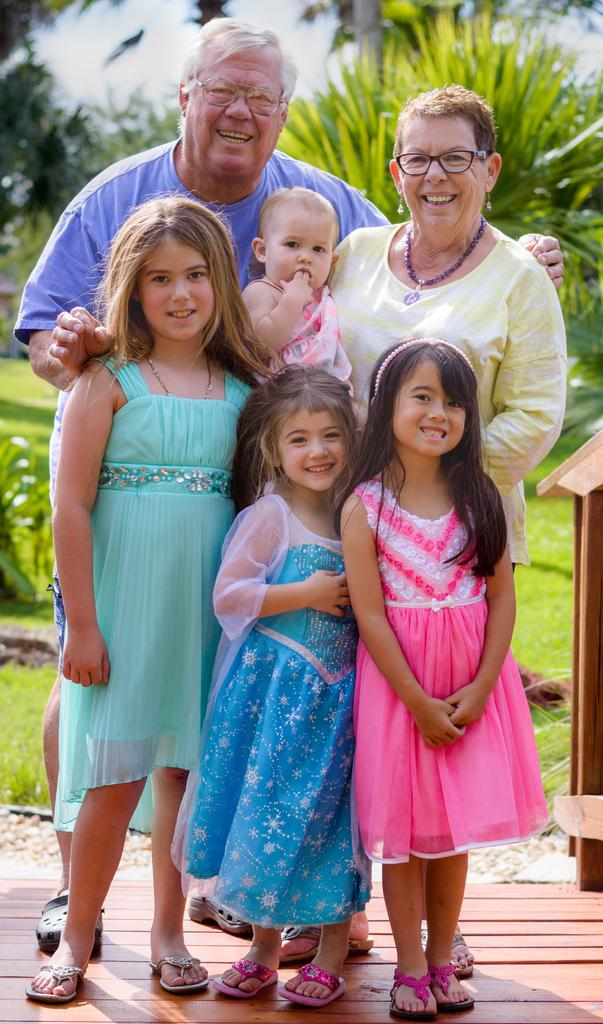What are the people in the image doing? The people in the image are standing on the floor and smiling. What can be seen in the background of the image? There is grass, pants, and the sky visible in the background of the image. What type of pear is being used to write prose in the image? There is no pear or prose present in the image. How does the burn on the person's hand affect their ability to stand in the image? There is no burn or indication of injury on any person in the image. 